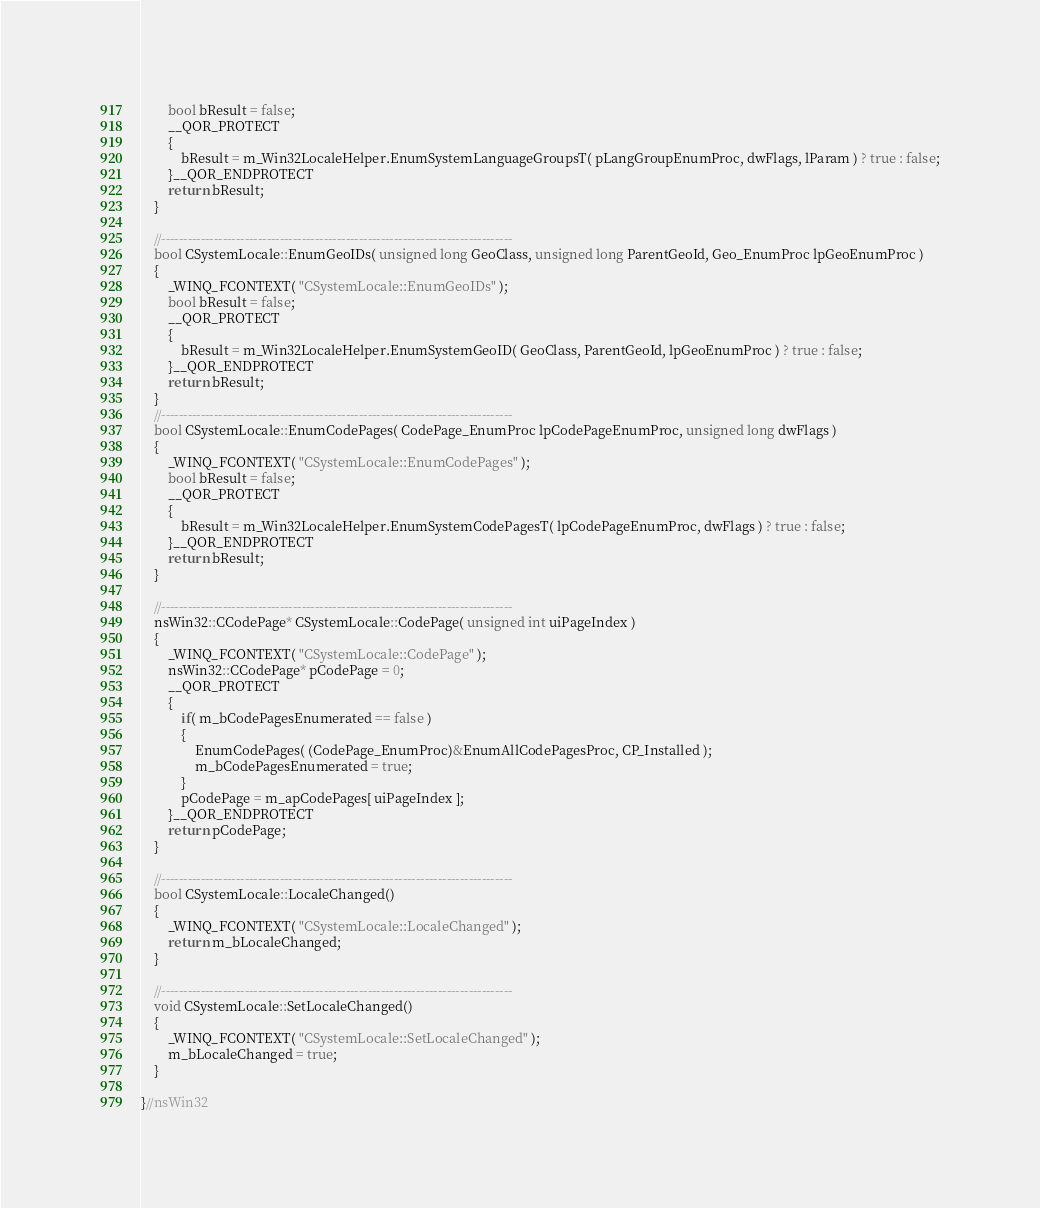<code> <loc_0><loc_0><loc_500><loc_500><_C++_>		bool bResult = false;
		__QOR_PROTECT
		{
			bResult = m_Win32LocaleHelper.EnumSystemLanguageGroupsT( pLangGroupEnumProc, dwFlags, lParam ) ? true : false;
		}__QOR_ENDPROTECT
		return bResult;
	}

	//--------------------------------------------------------------------------------
	bool CSystemLocale::EnumGeoIDs( unsigned long GeoClass, unsigned long ParentGeoId, Geo_EnumProc lpGeoEnumProc )
	{
		_WINQ_FCONTEXT( "CSystemLocale::EnumGeoIDs" );
		bool bResult = false;
		__QOR_PROTECT
		{
			bResult = m_Win32LocaleHelper.EnumSystemGeoID( GeoClass, ParentGeoId, lpGeoEnumProc ) ? true : false;
		}__QOR_ENDPROTECT
		return bResult;
	}
	//--------------------------------------------------------------------------------
	bool CSystemLocale::EnumCodePages( CodePage_EnumProc lpCodePageEnumProc, unsigned long dwFlags )
	{
		_WINQ_FCONTEXT( "CSystemLocale::EnumCodePages" );
		bool bResult = false;
		__QOR_PROTECT
		{
			bResult = m_Win32LocaleHelper.EnumSystemCodePagesT( lpCodePageEnumProc, dwFlags ) ? true : false;
		}__QOR_ENDPROTECT
		return bResult;
	}

	//--------------------------------------------------------------------------------
	nsWin32::CCodePage* CSystemLocale::CodePage( unsigned int uiPageIndex )
	{
		_WINQ_FCONTEXT( "CSystemLocale::CodePage" );
		nsWin32::CCodePage* pCodePage = 0;
		__QOR_PROTECT
		{
			if( m_bCodePagesEnumerated == false )
			{
				EnumCodePages( (CodePage_EnumProc)&EnumAllCodePagesProc, CP_Installed );
				m_bCodePagesEnumerated = true;
			}
			pCodePage = m_apCodePages[ uiPageIndex ];
		}__QOR_ENDPROTECT
		return pCodePage;
	}

	//--------------------------------------------------------------------------------
	bool CSystemLocale::LocaleChanged()
	{
		_WINQ_FCONTEXT( "CSystemLocale::LocaleChanged" );
		return m_bLocaleChanged;
	}

	//--------------------------------------------------------------------------------
	void CSystemLocale::SetLocaleChanged()
	{
		_WINQ_FCONTEXT( "CSystemLocale::SetLocaleChanged" );
		m_bLocaleChanged = true;
	}

}//nsWin32
</code> 